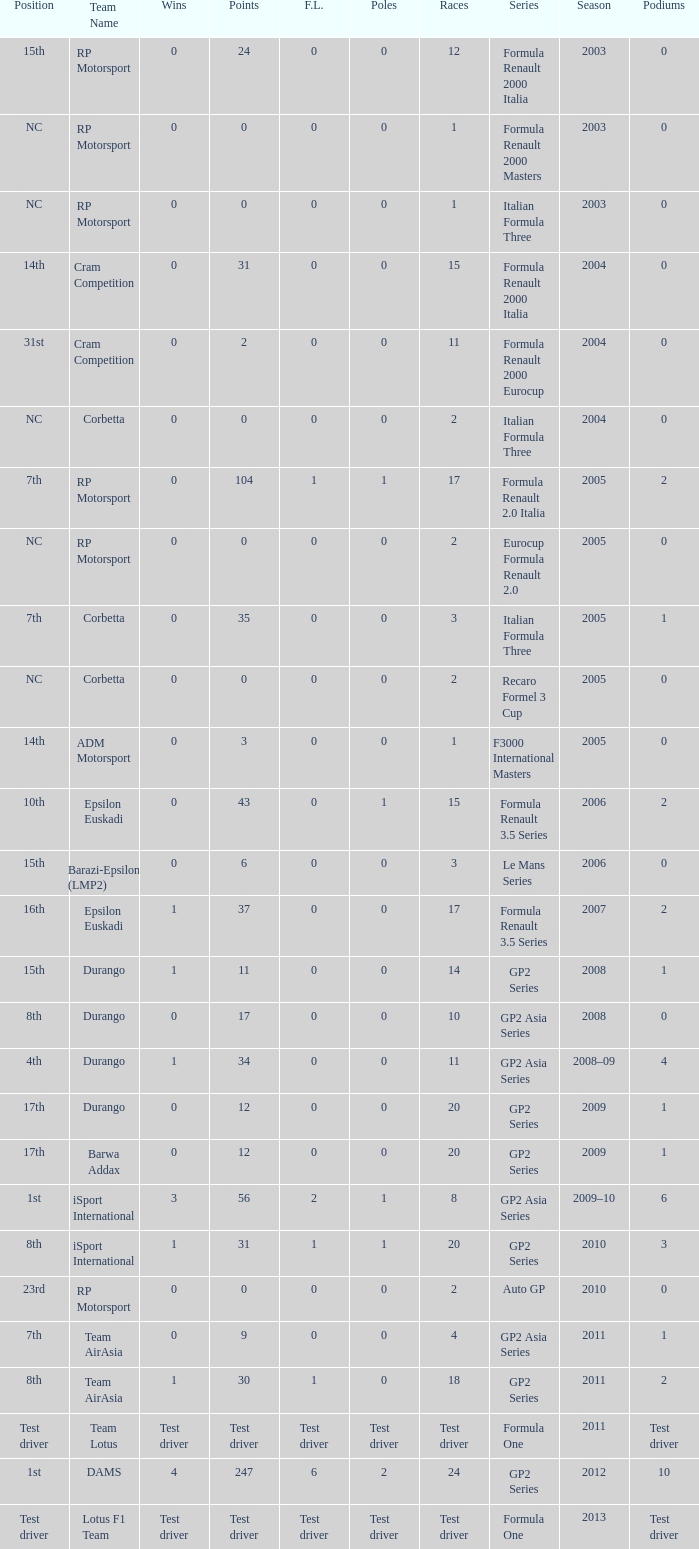What is the number of poles with 4 races? 0.0. I'm looking to parse the entire table for insights. Could you assist me with that? {'header': ['Position', 'Team Name', 'Wins', 'Points', 'F.L.', 'Poles', 'Races', 'Series', 'Season', 'Podiums'], 'rows': [['15th', 'RP Motorsport', '0', '24', '0', '0', '12', 'Formula Renault 2000 Italia', '2003', '0'], ['NC', 'RP Motorsport', '0', '0', '0', '0', '1', 'Formula Renault 2000 Masters', '2003', '0'], ['NC', 'RP Motorsport', '0', '0', '0', '0', '1', 'Italian Formula Three', '2003', '0'], ['14th', 'Cram Competition', '0', '31', '0', '0', '15', 'Formula Renault 2000 Italia', '2004', '0'], ['31st', 'Cram Competition', '0', '2', '0', '0', '11', 'Formula Renault 2000 Eurocup', '2004', '0'], ['NC', 'Corbetta', '0', '0', '0', '0', '2', 'Italian Formula Three', '2004', '0'], ['7th', 'RP Motorsport', '0', '104', '1', '1', '17', 'Formula Renault 2.0 Italia', '2005', '2'], ['NC', 'RP Motorsport', '0', '0', '0', '0', '2', 'Eurocup Formula Renault 2.0', '2005', '0'], ['7th', 'Corbetta', '0', '35', '0', '0', '3', 'Italian Formula Three', '2005', '1'], ['NC', 'Corbetta', '0', '0', '0', '0', '2', 'Recaro Formel 3 Cup', '2005', '0'], ['14th', 'ADM Motorsport', '0', '3', '0', '0', '1', 'F3000 International Masters', '2005', '0'], ['10th', 'Epsilon Euskadi', '0', '43', '0', '1', '15', 'Formula Renault 3.5 Series', '2006', '2'], ['15th', 'Barazi-Epsilon (LMP2)', '0', '6', '0', '0', '3', 'Le Mans Series', '2006', '0'], ['16th', 'Epsilon Euskadi', '1', '37', '0', '0', '17', 'Formula Renault 3.5 Series', '2007', '2'], ['15th', 'Durango', '1', '11', '0', '0', '14', 'GP2 Series', '2008', '1'], ['8th', 'Durango', '0', '17', '0', '0', '10', 'GP2 Asia Series', '2008', '0'], ['4th', 'Durango', '1', '34', '0', '0', '11', 'GP2 Asia Series', '2008–09', '4'], ['17th', 'Durango', '0', '12', '0', '0', '20', 'GP2 Series', '2009', '1'], ['17th', 'Barwa Addax', '0', '12', '0', '0', '20', 'GP2 Series', '2009', '1'], ['1st', 'iSport International', '3', '56', '2', '1', '8', 'GP2 Asia Series', '2009–10', '6'], ['8th', 'iSport International', '1', '31', '1', '1', '20', 'GP2 Series', '2010', '3'], ['23rd', 'RP Motorsport', '0', '0', '0', '0', '2', 'Auto GP', '2010', '0'], ['7th', 'Team AirAsia', '0', '9', '0', '0', '4', 'GP2 Asia Series', '2011', '1'], ['8th', 'Team AirAsia', '1', '30', '1', '0', '18', 'GP2 Series', '2011', '2'], ['Test driver', 'Team Lotus', 'Test driver', 'Test driver', 'Test driver', 'Test driver', 'Test driver', 'Formula One', '2011', 'Test driver'], ['1st', 'DAMS', '4', '247', '6', '2', '24', 'GP2 Series', '2012', '10'], ['Test driver', 'Lotus F1 Team', 'Test driver', 'Test driver', 'Test driver', 'Test driver', 'Test driver', 'Formula One', '2013', 'Test driver']]} 